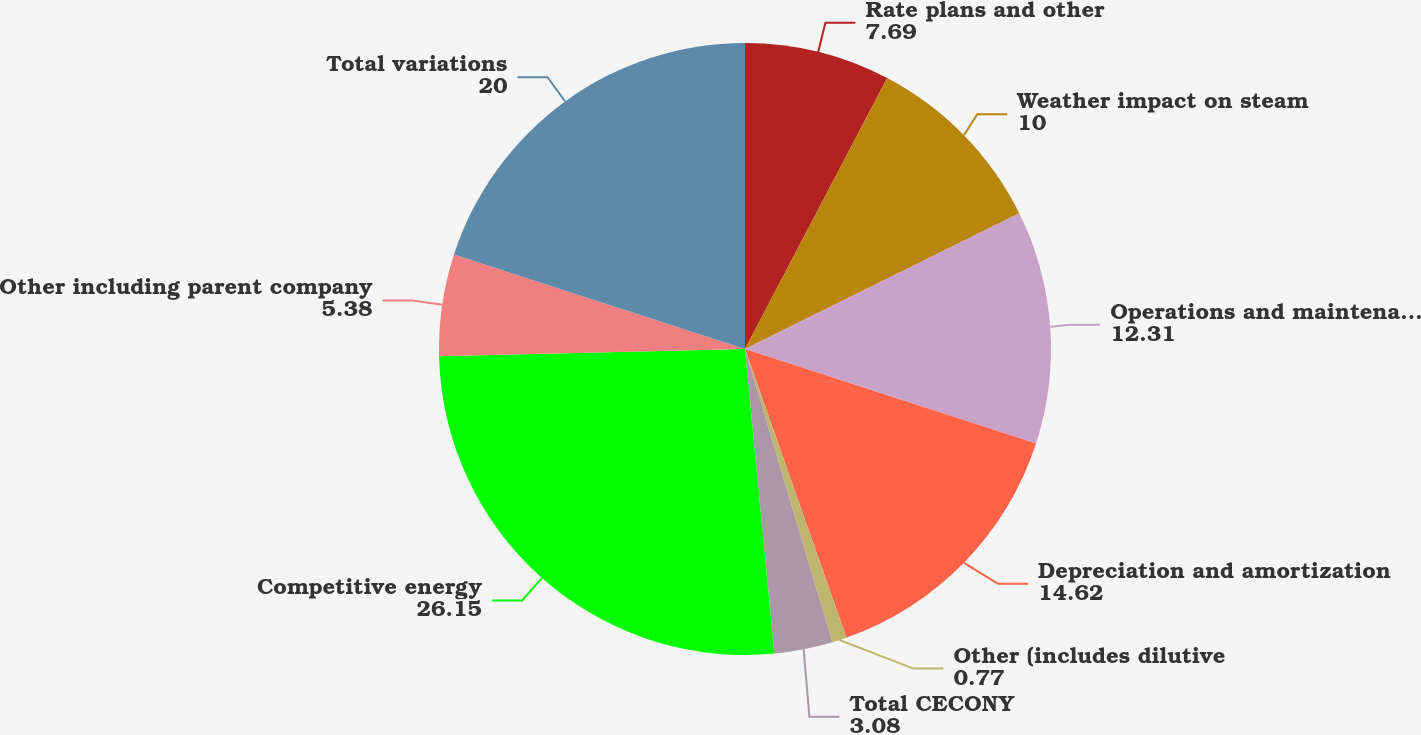Convert chart to OTSL. <chart><loc_0><loc_0><loc_500><loc_500><pie_chart><fcel>Rate plans and other<fcel>Weather impact on steam<fcel>Operations and maintenance<fcel>Depreciation and amortization<fcel>Other (includes dilutive<fcel>Total CECONY<fcel>Competitive energy<fcel>Other including parent company<fcel>Total variations<nl><fcel>7.69%<fcel>10.0%<fcel>12.31%<fcel>14.62%<fcel>0.77%<fcel>3.08%<fcel>26.15%<fcel>5.38%<fcel>20.0%<nl></chart> 